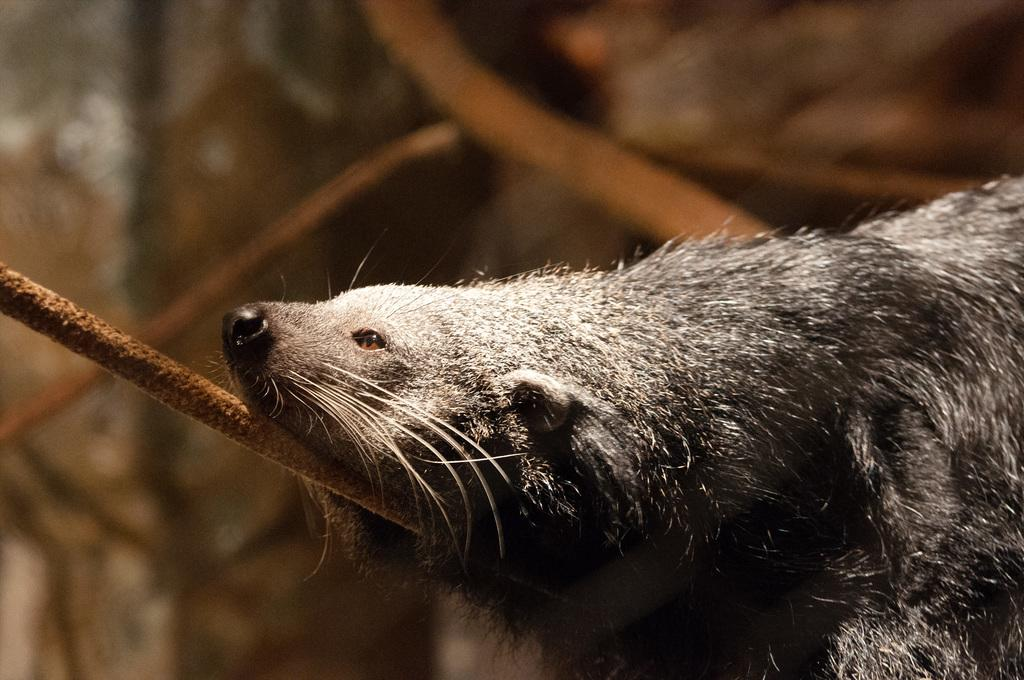What animal is the main subject of the image? There is a sea otter in the image. What is the sea otter resting on? The sea otter is on an iron rod. Can you describe the background of the image? The background of the image is blurred. Where is the picnic table located in the image? There is no picnic table present in the image. What type of food is the sea otter eating in the image? The image does not show the sea otter eating any food. 